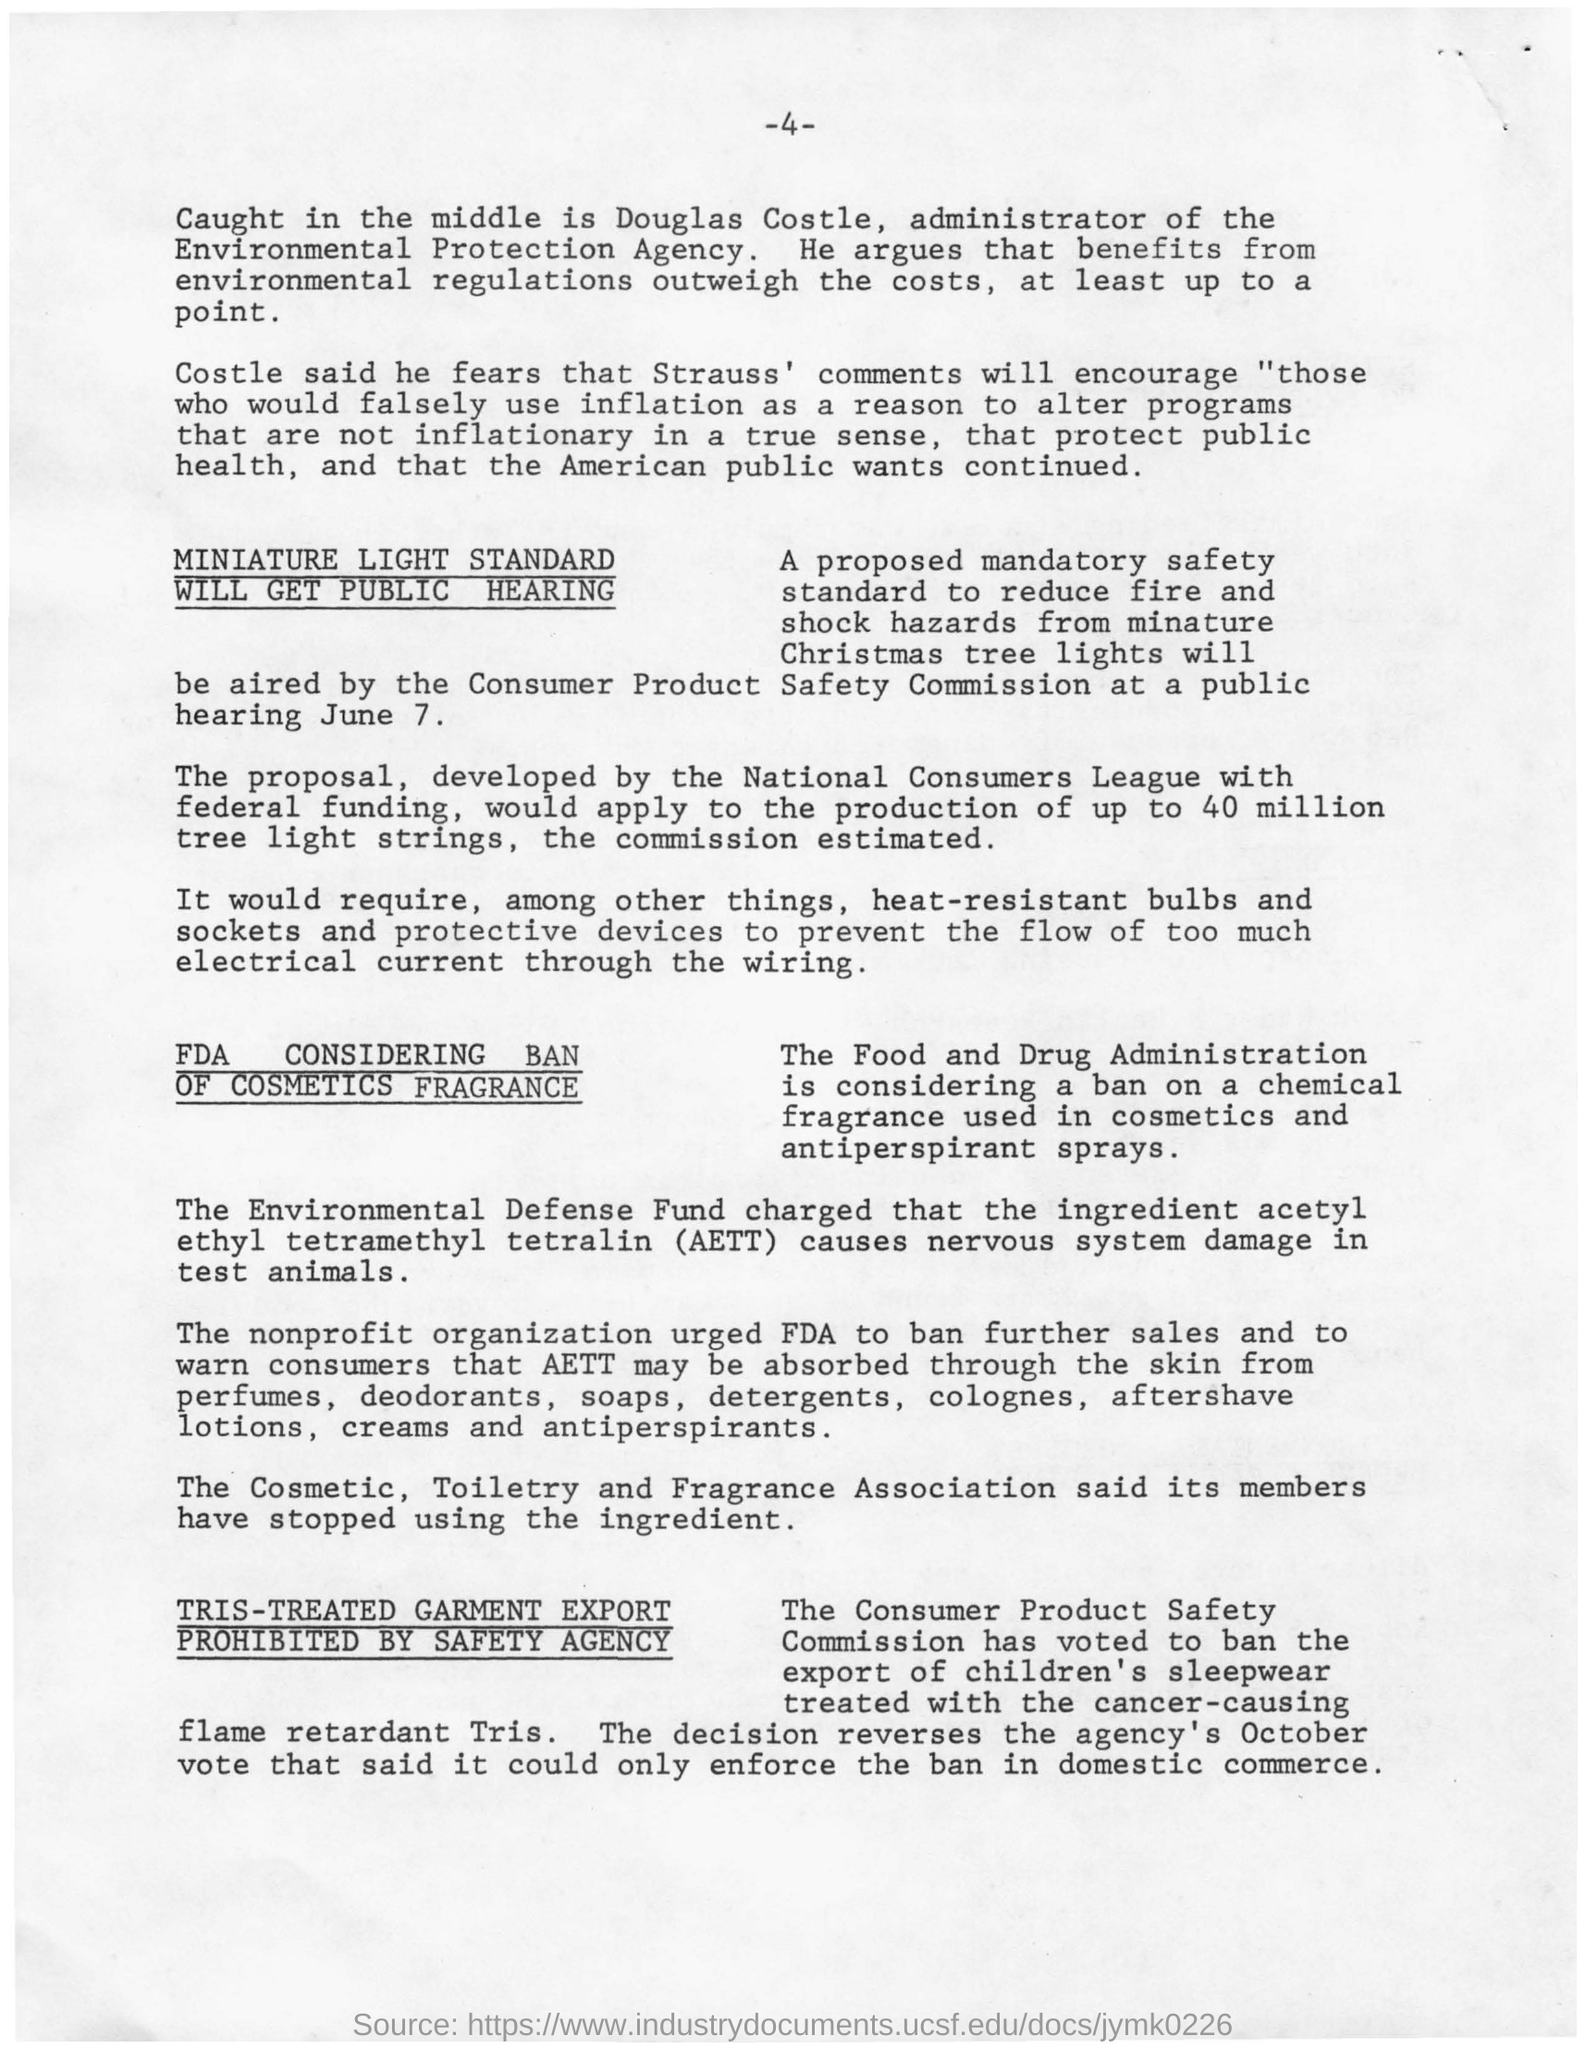Mention a couple of crucial points in this snapshot. The page number mentioned in this document is 4. Acetyl ethyl tetramethyl tetralin, commonly abbreviated as AETT, is a colorless liquid with a characteristic odor. It is used as a solvent and as a starting material in the production of a variety of chemicals. AETT is a complex organic compound consisting of four ethyl groups and two acetyl groups, which are connected by a methylene bridge. 